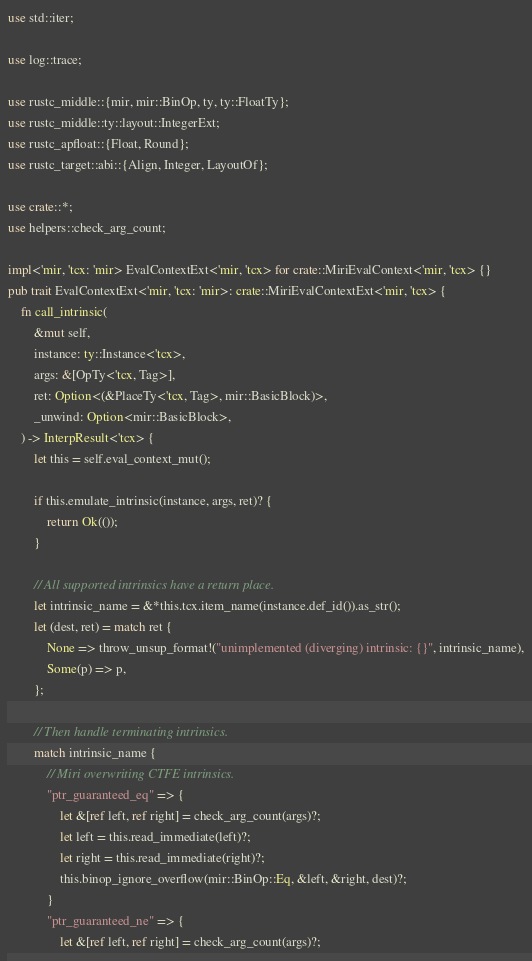<code> <loc_0><loc_0><loc_500><loc_500><_Rust_>use std::iter;

use log::trace;

use rustc_middle::{mir, mir::BinOp, ty, ty::FloatTy};
use rustc_middle::ty::layout::IntegerExt;
use rustc_apfloat::{Float, Round};
use rustc_target::abi::{Align, Integer, LayoutOf};

use crate::*;
use helpers::check_arg_count;

impl<'mir, 'tcx: 'mir> EvalContextExt<'mir, 'tcx> for crate::MiriEvalContext<'mir, 'tcx> {}
pub trait EvalContextExt<'mir, 'tcx: 'mir>: crate::MiriEvalContextExt<'mir, 'tcx> {
    fn call_intrinsic(
        &mut self,
        instance: ty::Instance<'tcx>,
        args: &[OpTy<'tcx, Tag>],
        ret: Option<(&PlaceTy<'tcx, Tag>, mir::BasicBlock)>,
        _unwind: Option<mir::BasicBlock>,
    ) -> InterpResult<'tcx> {
        let this = self.eval_context_mut();

        if this.emulate_intrinsic(instance, args, ret)? {
            return Ok(());
        }

        // All supported intrinsics have a return place.
        let intrinsic_name = &*this.tcx.item_name(instance.def_id()).as_str();
        let (dest, ret) = match ret {
            None => throw_unsup_format!("unimplemented (diverging) intrinsic: {}", intrinsic_name),
            Some(p) => p,
        };

        // Then handle terminating intrinsics.
        match intrinsic_name {
            // Miri overwriting CTFE intrinsics.
            "ptr_guaranteed_eq" => {
                let &[ref left, ref right] = check_arg_count(args)?;
                let left = this.read_immediate(left)?;
                let right = this.read_immediate(right)?;
                this.binop_ignore_overflow(mir::BinOp::Eq, &left, &right, dest)?;
            }
            "ptr_guaranteed_ne" => {
                let &[ref left, ref right] = check_arg_count(args)?;</code> 